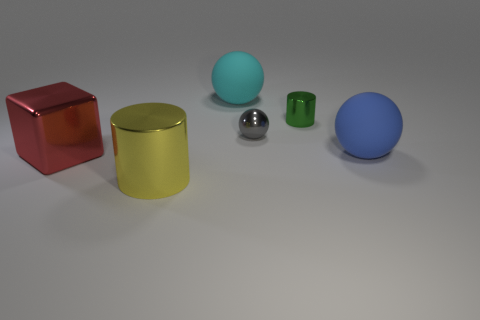What materials do the objects in the image appear to be made of? The objects in the image appear to be made from various shiny and matte materials. The red and gold objects have a metallic, reflective surface, suggesting they might be made of metal. The green object has a slightly shiny, plastic-like appearance, and the spheres (blue and matte grey) could be ceramic or plastic based on their finish. 